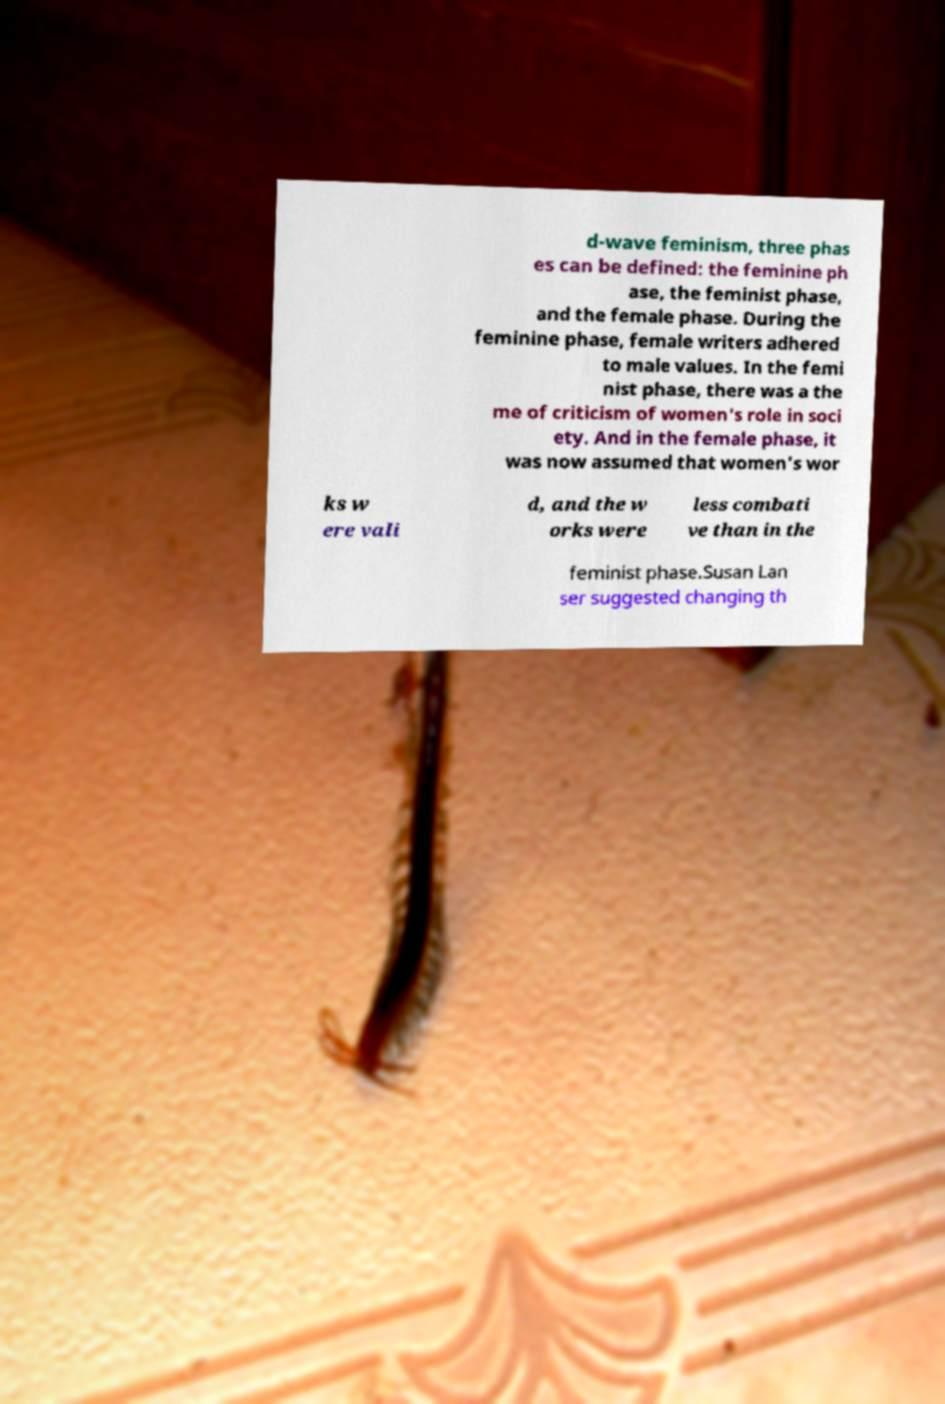For documentation purposes, I need the text within this image transcribed. Could you provide that? d-wave feminism, three phas es can be defined: the feminine ph ase, the feminist phase, and the female phase. During the feminine phase, female writers adhered to male values. In the femi nist phase, there was a the me of criticism of women's role in soci ety. And in the female phase, it was now assumed that women's wor ks w ere vali d, and the w orks were less combati ve than in the feminist phase.Susan Lan ser suggested changing th 